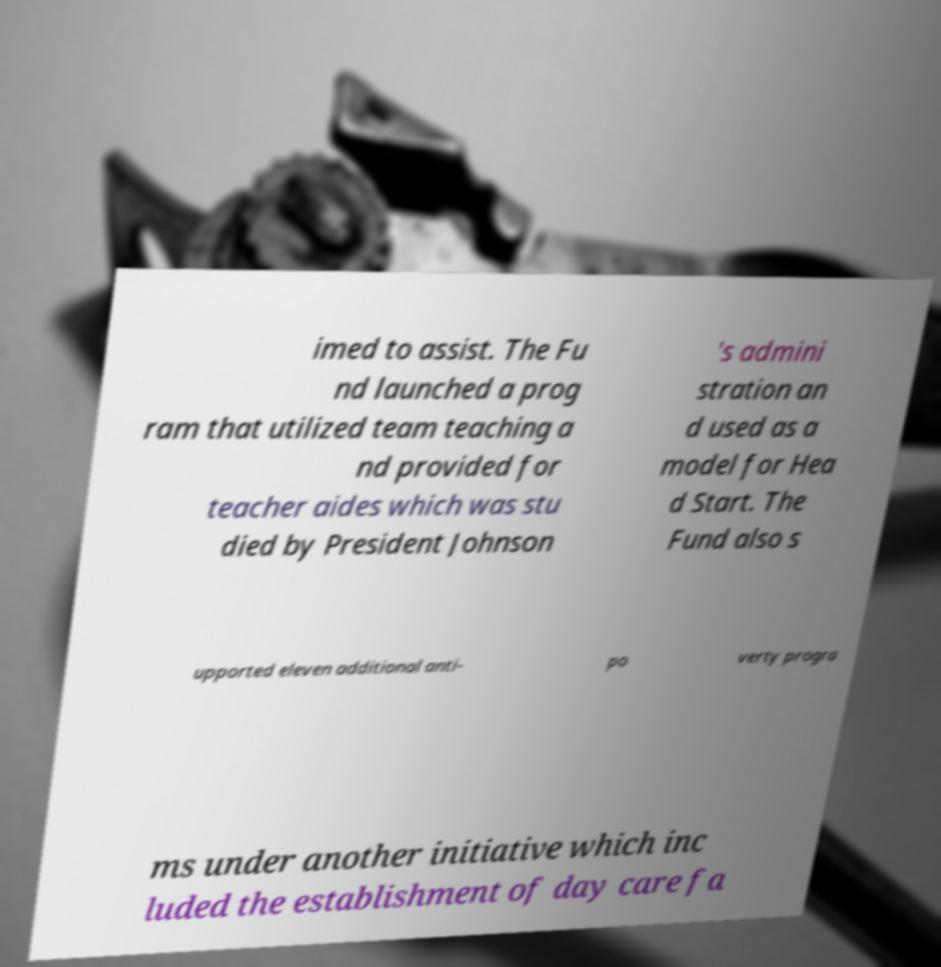For documentation purposes, I need the text within this image transcribed. Could you provide that? imed to assist. The Fu nd launched a prog ram that utilized team teaching a nd provided for teacher aides which was stu died by President Johnson 's admini stration an d used as a model for Hea d Start. The Fund also s upported eleven additional anti- po verty progra ms under another initiative which inc luded the establishment of day care fa 